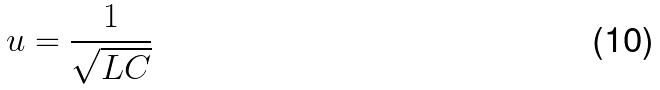<formula> <loc_0><loc_0><loc_500><loc_500>u = \frac { 1 } { \sqrt { L C } }</formula> 